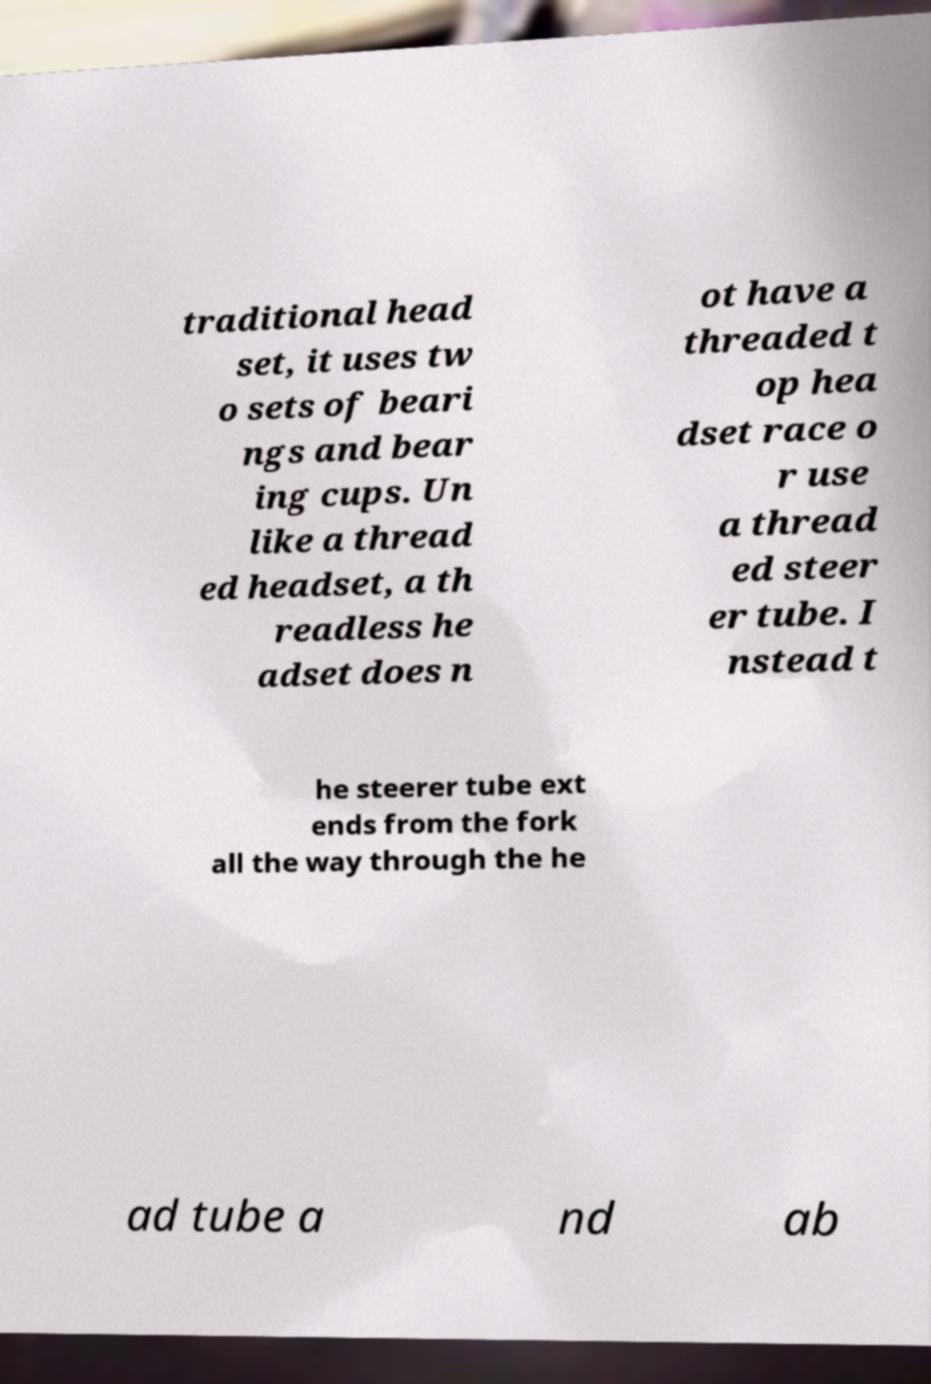What messages or text are displayed in this image? I need them in a readable, typed format. traditional head set, it uses tw o sets of beari ngs and bear ing cups. Un like a thread ed headset, a th readless he adset does n ot have a threaded t op hea dset race o r use a thread ed steer er tube. I nstead t he steerer tube ext ends from the fork all the way through the he ad tube a nd ab 